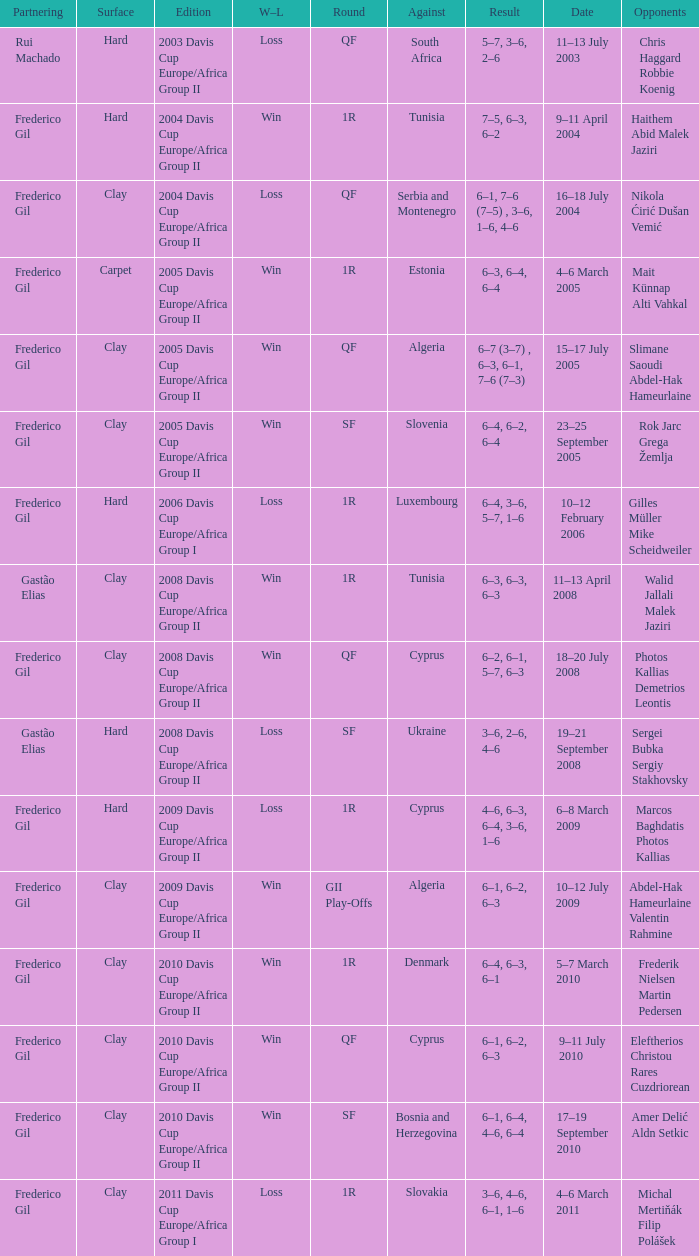How many rounds were there in the 2006 davis cup europe/africa group I? 1.0. 